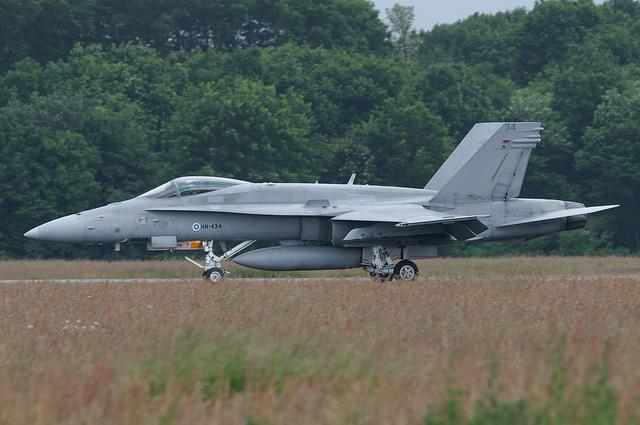What is the main color on the plane?
Concise answer only. Gray. What color is the jet?
Write a very short answer. Gray. Is this a jet?
Give a very brief answer. Yes. Does the jet belong to the military?
Be succinct. Yes. 